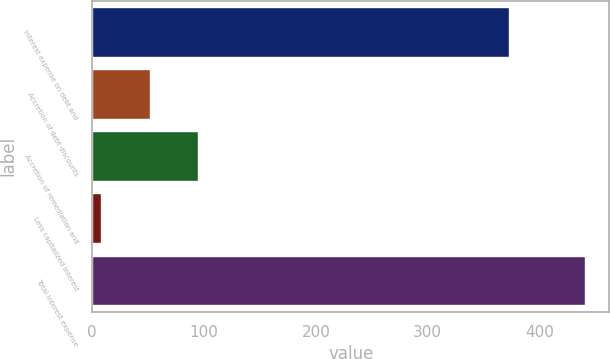<chart> <loc_0><loc_0><loc_500><loc_500><bar_chart><fcel>Interest expense on debt and<fcel>Accretion of debt discounts<fcel>Accretion of remediation and<fcel>Less capitalized interest<fcel>Total interest expense<nl><fcel>372.9<fcel>51.31<fcel>94.52<fcel>8.1<fcel>440.2<nl></chart> 